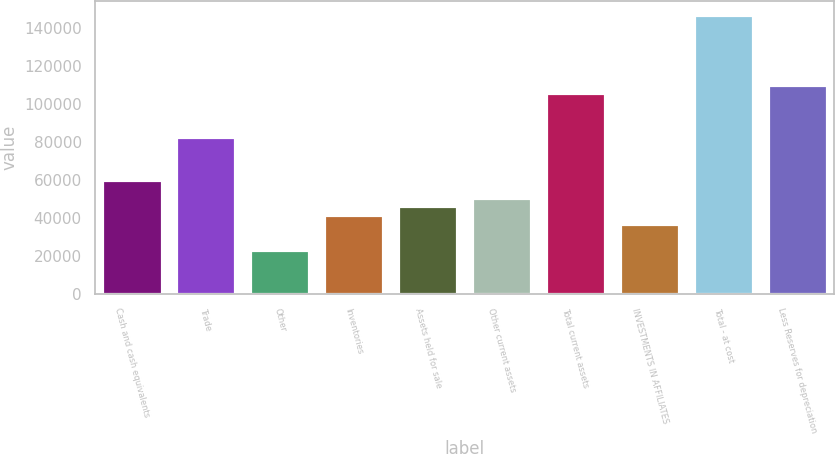<chart> <loc_0><loc_0><loc_500><loc_500><bar_chart><fcel>Cash and cash equivalents<fcel>Trade<fcel>Other<fcel>Inventories<fcel>Assets held for sale<fcel>Other current assets<fcel>Total current assets<fcel>INVESTMENTS IN AFFILIATES<fcel>Total - at cost<fcel>Less Reserves for depreciation<nl><fcel>59715.8<fcel>82658.8<fcel>23007<fcel>41361.4<fcel>45950<fcel>50538.6<fcel>105602<fcel>36772.8<fcel>146899<fcel>110190<nl></chart> 